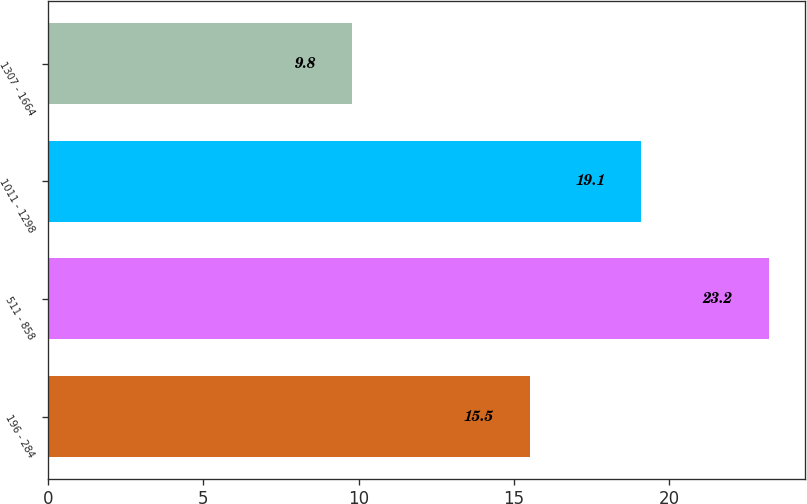Convert chart to OTSL. <chart><loc_0><loc_0><loc_500><loc_500><bar_chart><fcel>196 - 284<fcel>511 - 858<fcel>1011 - 1298<fcel>1307 - 1664<nl><fcel>15.5<fcel>23.2<fcel>19.1<fcel>9.8<nl></chart> 